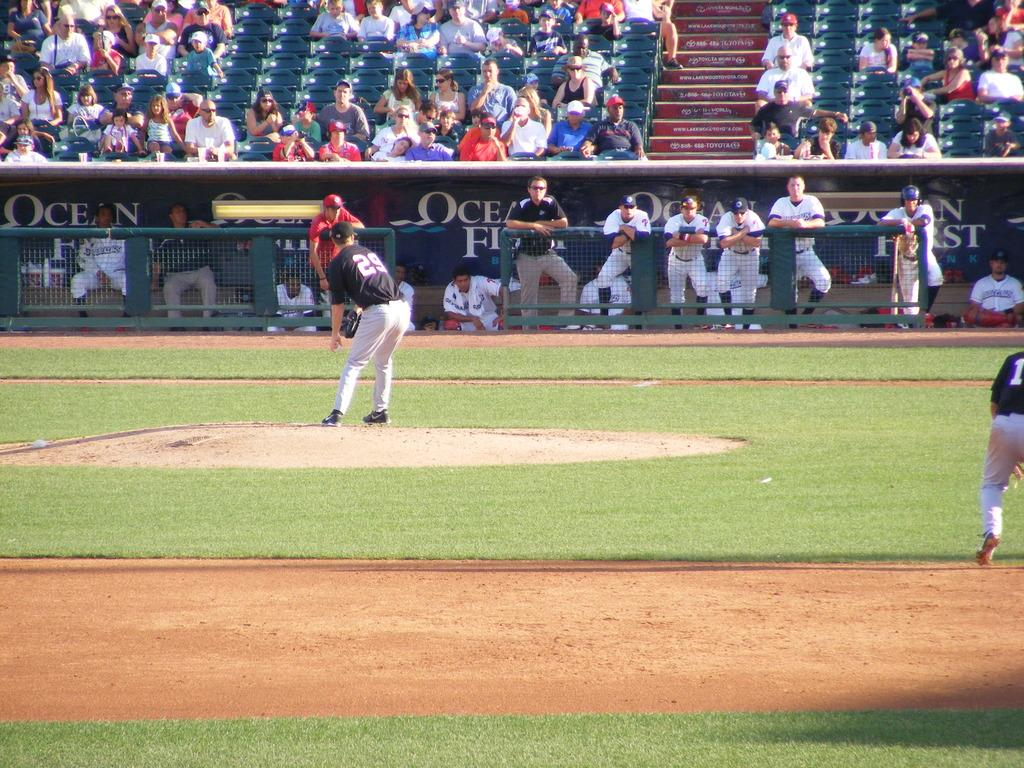Provide a one-sentence caption for the provided image. A pitcher at a baseball game with the number 29 on his back. 